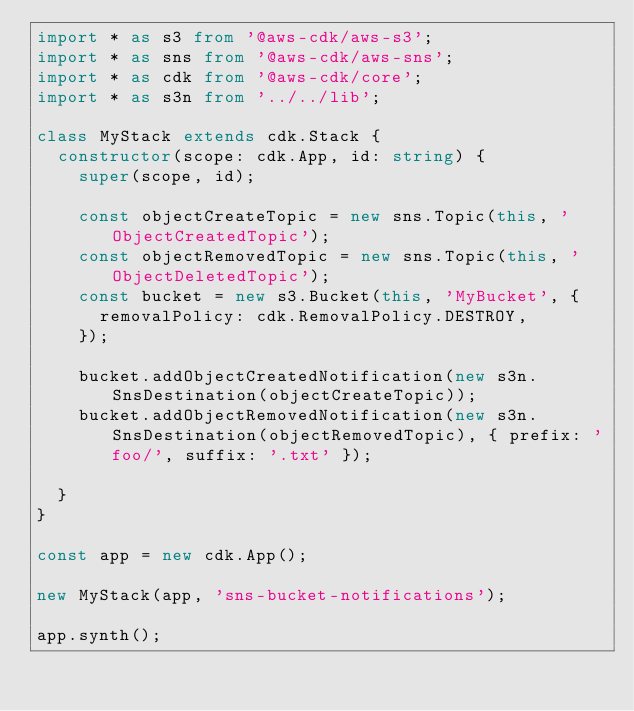Convert code to text. <code><loc_0><loc_0><loc_500><loc_500><_TypeScript_>import * as s3 from '@aws-cdk/aws-s3';
import * as sns from '@aws-cdk/aws-sns';
import * as cdk from '@aws-cdk/core';
import * as s3n from '../../lib';

class MyStack extends cdk.Stack {
  constructor(scope: cdk.App, id: string) {
    super(scope, id);

    const objectCreateTopic = new sns.Topic(this, 'ObjectCreatedTopic');
    const objectRemovedTopic = new sns.Topic(this, 'ObjectDeletedTopic');
    const bucket = new s3.Bucket(this, 'MyBucket', {
      removalPolicy: cdk.RemovalPolicy.DESTROY,
    });

    bucket.addObjectCreatedNotification(new s3n.SnsDestination(objectCreateTopic));
    bucket.addObjectRemovedNotification(new s3n.SnsDestination(objectRemovedTopic), { prefix: 'foo/', suffix: '.txt' });

  }
}

const app = new cdk.App();

new MyStack(app, 'sns-bucket-notifications');

app.synth();
</code> 